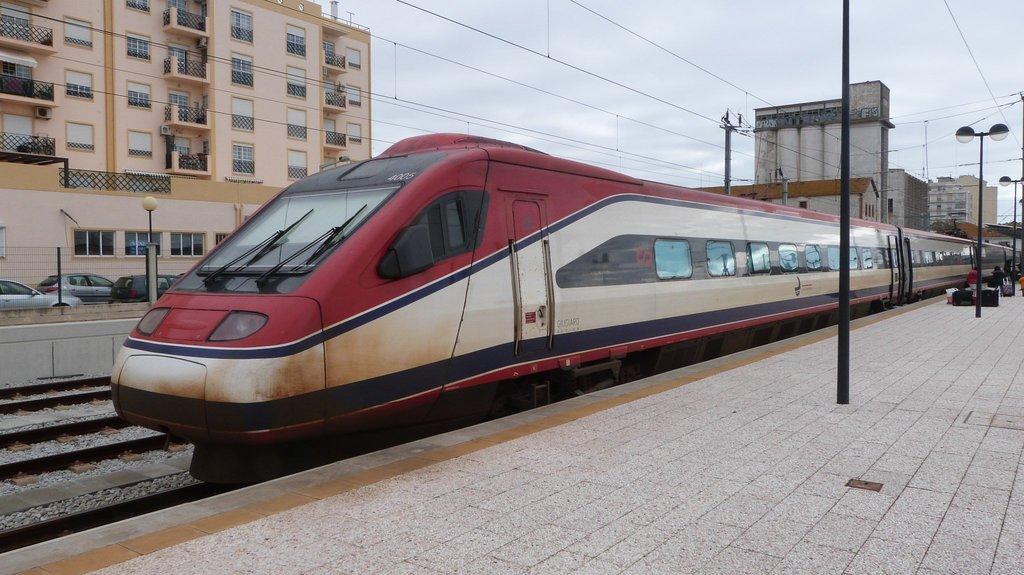In one or two sentences, can you explain what this image depicts? In this image we can see a metro train and station. Behind the train buildings are present and cars are parked. 